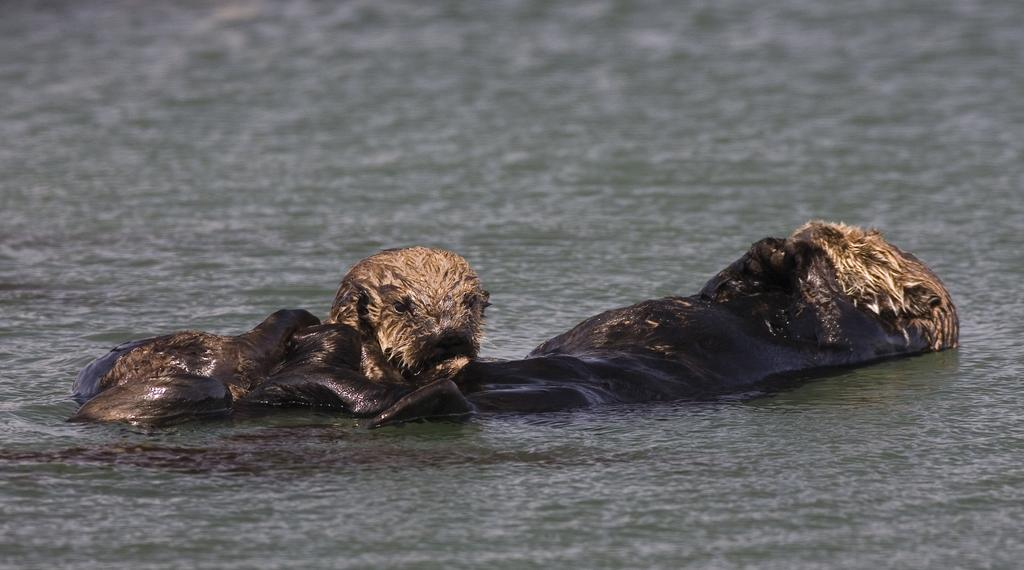What type of natural feature is present in the image? There is a small river in the image. What are the two animals doing in the image? The two animals are swimming in the water. Can you tell me how many tomatoes are being carried by the man in the image? There is no man present in the image, and therefore no tomatoes being carried. What type of shoes is the man wearing while walking in the image? There is no man present in the image, so it is not possible to determine the type of shoes he might be wearing. 